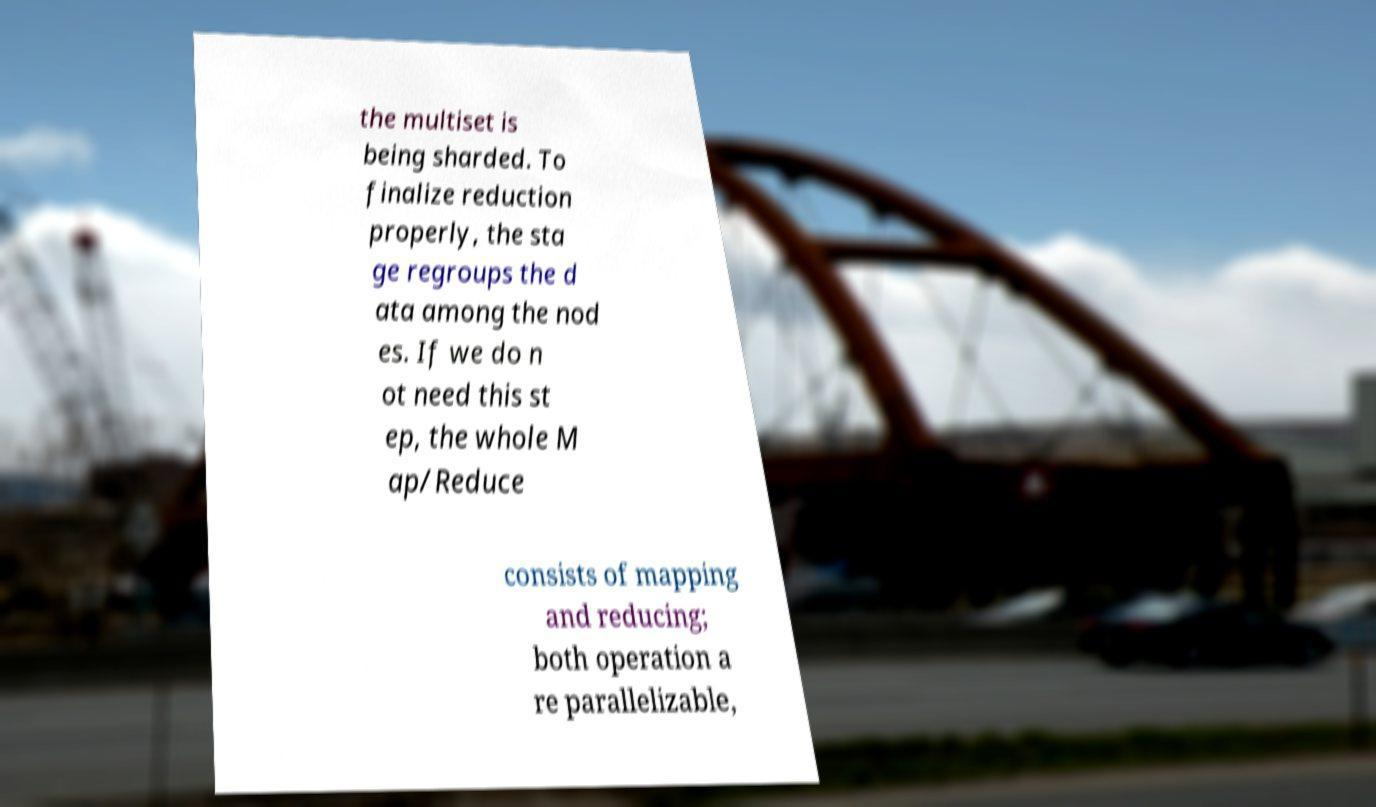Could you assist in decoding the text presented in this image and type it out clearly? the multiset is being sharded. To finalize reduction properly, the sta ge regroups the d ata among the nod es. If we do n ot need this st ep, the whole M ap/Reduce consists of mapping and reducing; both operation a re parallelizable, 